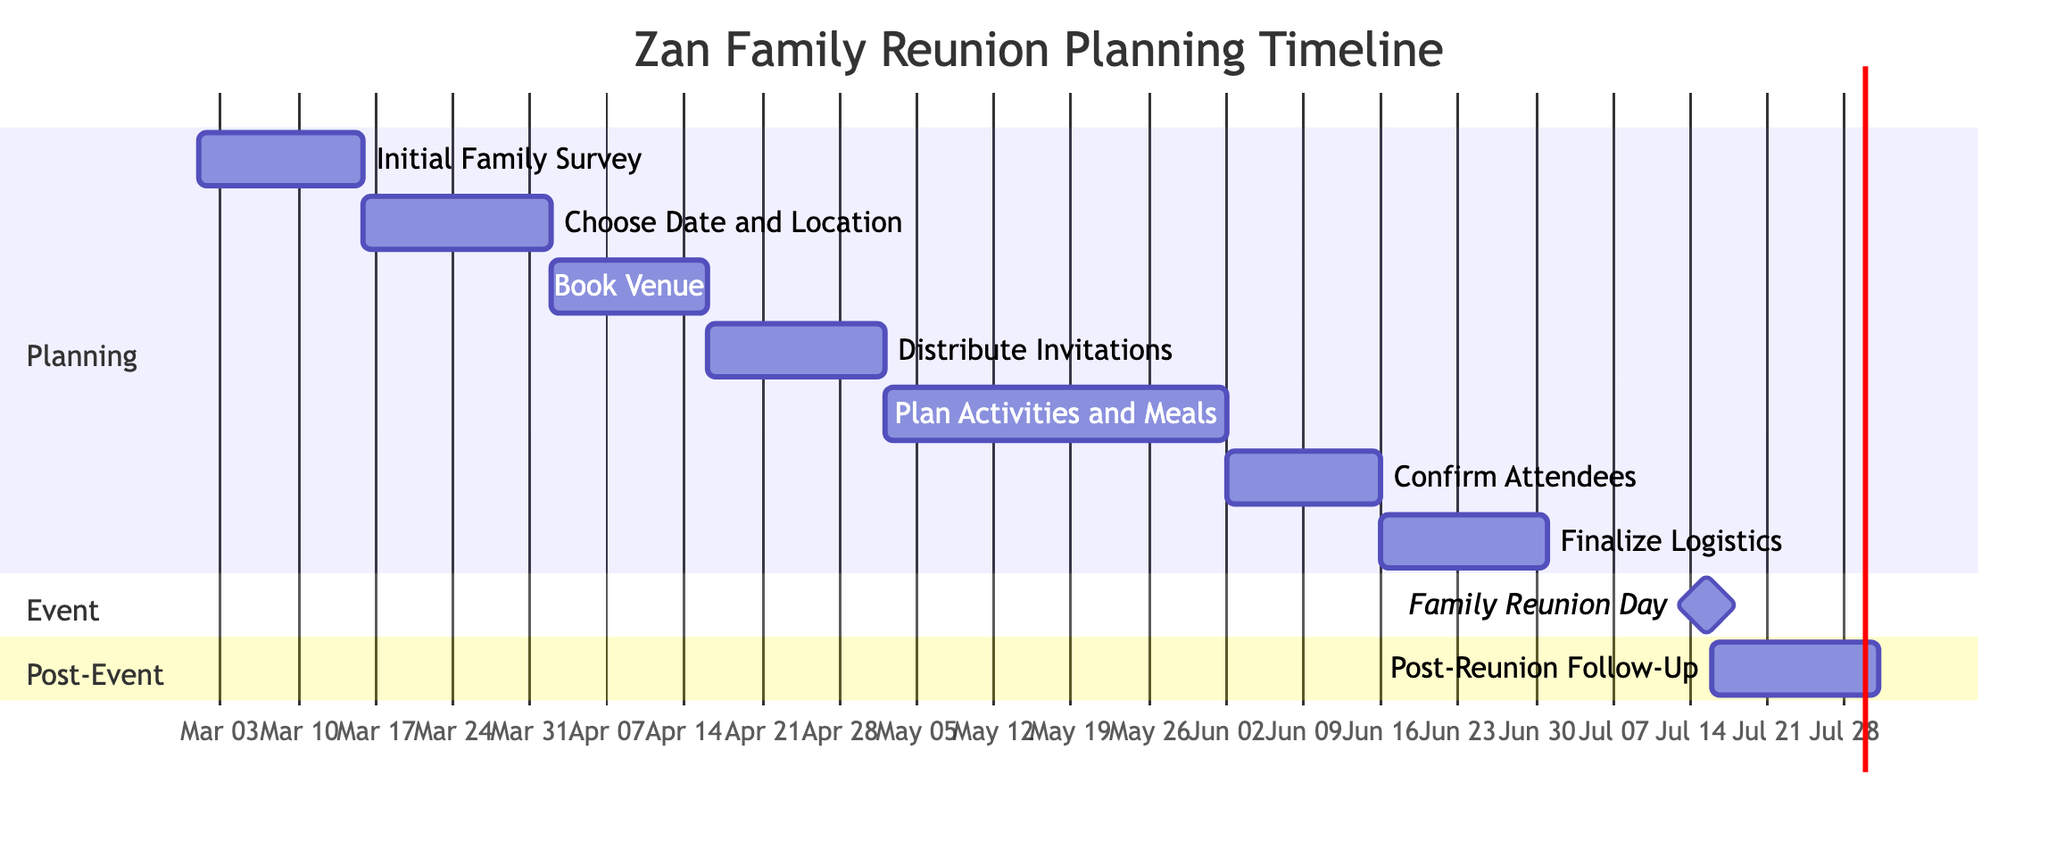What is the duration of the "Choose Date and Location" task? The task "Choose Date and Location" starts on March 16, 2024, and ends on April 1, 2024. Counting the days between these dates gives a duration of 17 days.
Answer: 17 days What task immediately follows "Book Venue" in the timeline? The task "Book Venue" ends on April 15, 2024. The next task listed after this date is "Distribute Invitations," which starts on April 16, 2024.
Answer: Distribute Invitations How many total tasks are listed in the Gantt chart? The Gantt chart contains a total of 9 tasks when counting both planning and event sections.
Answer: 9 tasks What is the start date of the "Confirm Attendees" task? The "Confirm Attendees" task starts on June 2, 2024, which is explicitly stated in the chart.
Answer: June 2, 2024 Which task is a milestone in the diagram? The diagram identifies "Family Reunion Day" as a milestone, indicated by the term used and its unique representation as a single day event.
Answer: Family Reunion Day What is the total duration for the entire planning period from the start of "Initial Family Survey" to the end of "Finalize Logistics"? The "Initial Family Survey" starts on March 1, 2024, and "Finalize Logistics" ends on June 30, 2024. The duration from the beginning to the end is 121 days.
Answer: 121 days How does the "Post-Reunion Follow-Up" relate in timing to the "Family Reunion Day"? The "Post-Reunion Follow-Up" starts the day after the "Family Reunion Day," indicating a direct chronological relationship in the timeline, as it begins on July 16, 2024, right after the reunion on July 15, 2024.
Answer: Starts the day after What is the end date for the "Plan Activities and Meals" task? The "Plan Activities and Meals" task is shown to end on June 1, 2024, as stated in the diagram.
Answer: June 1, 2024 What section contains the task "Finalize Logistics"? "Finalize Logistics" is located in the Planning section of the Gantt chart, as categorized under planning tasks before the event dates.
Answer: Planning section 